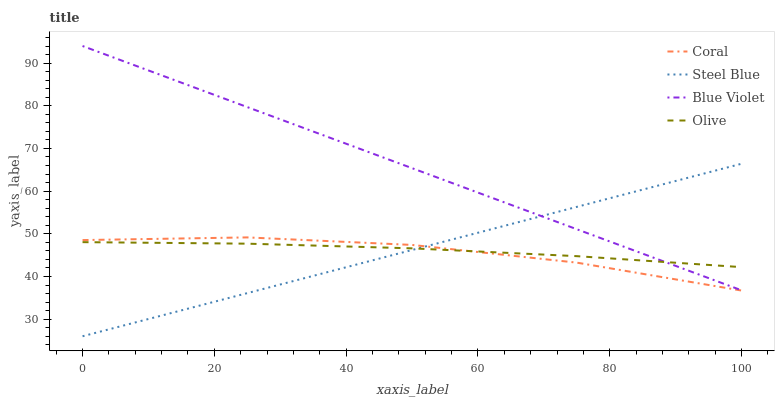Does Coral have the minimum area under the curve?
Answer yes or no. Yes. Does Blue Violet have the maximum area under the curve?
Answer yes or no. Yes. Does Steel Blue have the minimum area under the curve?
Answer yes or no. No. Does Steel Blue have the maximum area under the curve?
Answer yes or no. No. Is Steel Blue the smoothest?
Answer yes or no. Yes. Is Coral the roughest?
Answer yes or no. Yes. Is Coral the smoothest?
Answer yes or no. No. Is Steel Blue the roughest?
Answer yes or no. No. Does Steel Blue have the lowest value?
Answer yes or no. Yes. Does Coral have the lowest value?
Answer yes or no. No. Does Blue Violet have the highest value?
Answer yes or no. Yes. Does Coral have the highest value?
Answer yes or no. No. Is Coral less than Blue Violet?
Answer yes or no. Yes. Is Blue Violet greater than Coral?
Answer yes or no. Yes. Does Blue Violet intersect Steel Blue?
Answer yes or no. Yes. Is Blue Violet less than Steel Blue?
Answer yes or no. No. Is Blue Violet greater than Steel Blue?
Answer yes or no. No. Does Coral intersect Blue Violet?
Answer yes or no. No. 